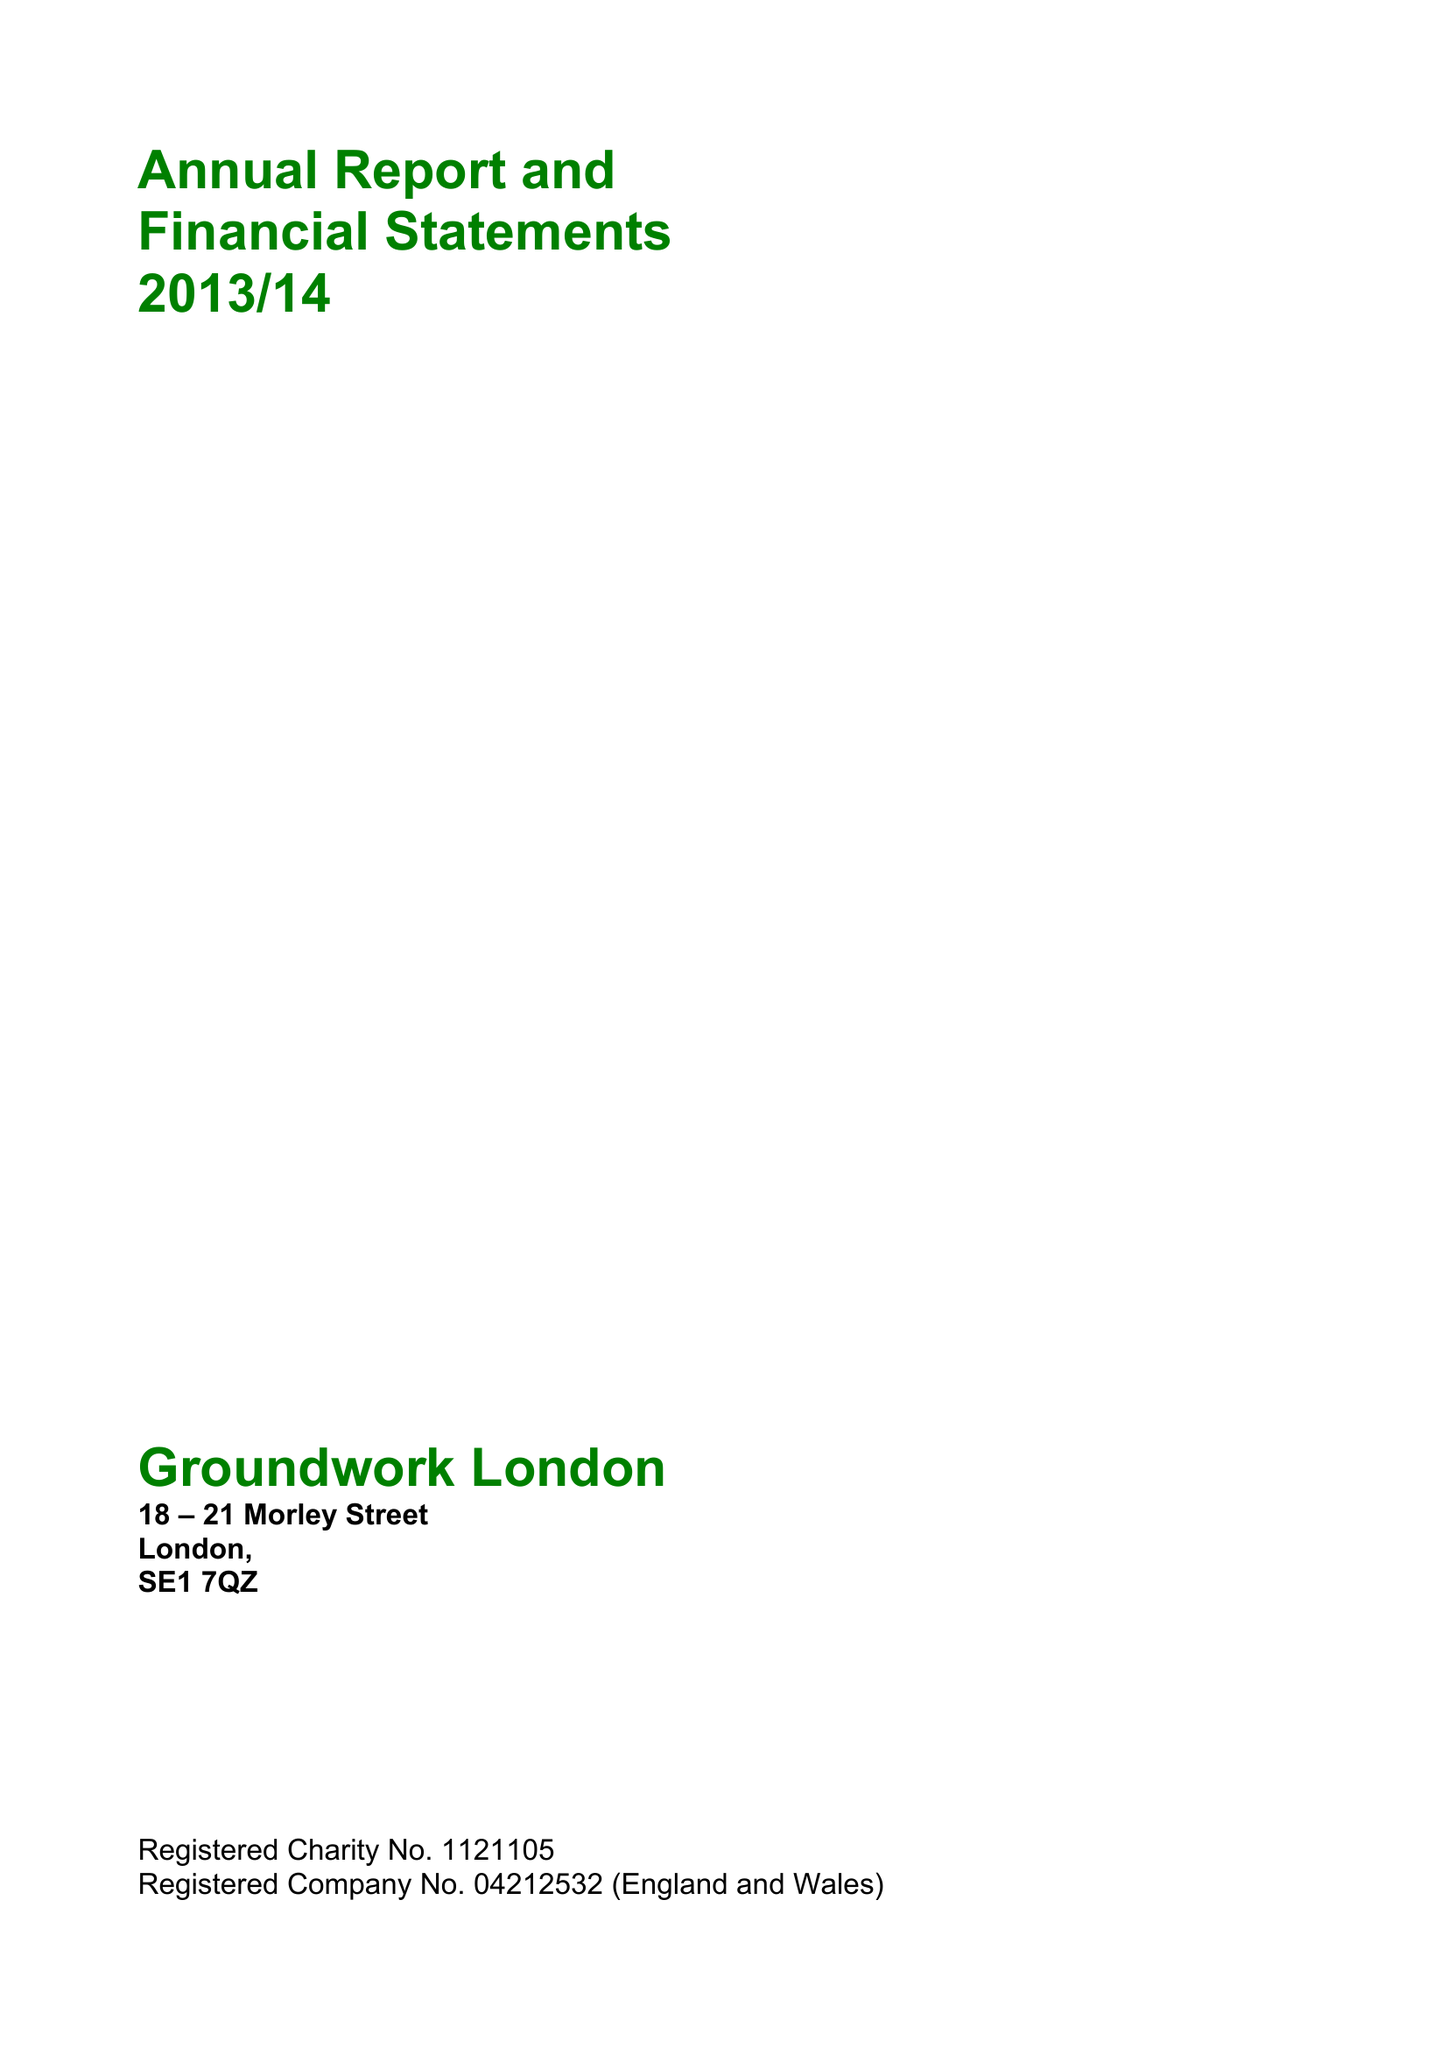What is the value for the report_date?
Answer the question using a single word or phrase. 2014-03-31 